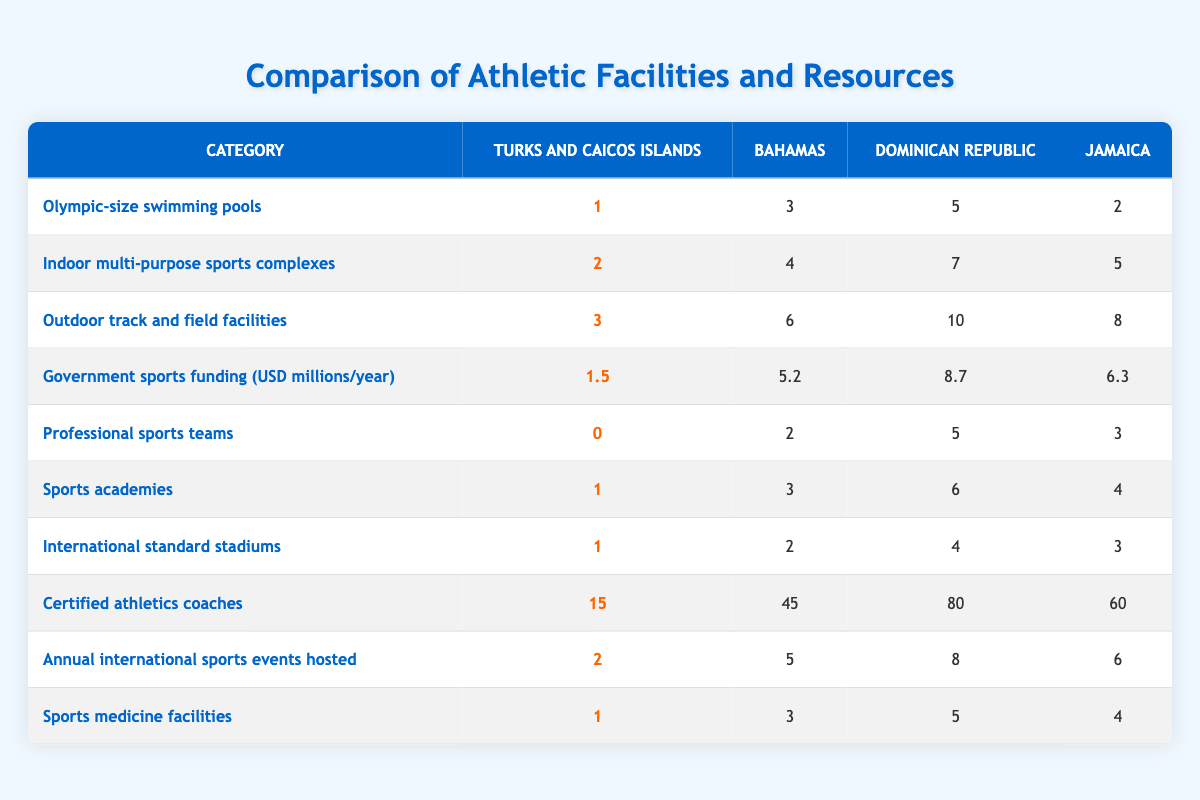What is the number of Olympic-size swimming pools in the Dominican Republic? The table shows that the Dominican Republic has 5 Olympic-size swimming pools listed under that category.
Answer: 5 Which country has the highest government sports funding? By looking at the government sports funding values, the Dominican Republic has the highest funding at 8.7 million USD per year.
Answer: Dominican Republic How many more certified athletics coaches does Jamaica have compared to the Turks and Caicos Islands? Jamaica has 60 certified athletics coaches and Turks and Caicos Islands has 15. The difference is 60 - 15 = 45.
Answer: 45 Do the Turks and Caicos Islands have more or fewer professional sports teams than the Bahamas? The Turks and Caicos Islands have 0 professional sports teams while the Bahamas have 2. Thus, Turks and Caicos has fewer professional teams.
Answer: Fewer What is the total number of outdoor track and field facilities across all four countries? Summing the outdoor track and field facilities: 3 (Turks and Caicos) + 6 (Bahamas) + 10 (Dominican Republic) + 8 (Jamaica) gives a total of 27 facilities.
Answer: 27 Which country has the least number of sports academies, and how many do they have? Turks and Caicos Islands has the least number of sports academies at 1, as seen in the comparison table.
Answer: Turks and Caicos Islands, 1 What is the average number of annual international sports events hosted by these countries? Adding the annual international sports events has the following values: 2 (Turks and Caicos) + 5 (Bahamas) + 8 (Dominican Republic) + 6 (Jamaica) = 21. Divided by 4 (the number of countries) gives an average of 21 / 4 = 5.25.
Answer: 5.25 Which country has the most international standard stadiums, and how many do they have? From the table, the Dominican Republic has the most international standard stadiums listed with a total of 4.
Answer: Dominican Republic, 4 What is the difference in the number of indoor multi-purpose sports complexes between the Dominican Republic and the Bahamas? The Dominican Republic has 7 indoor multi-purpose sports complexes and the Bahamas has 4. The difference is 7 - 4 = 3.
Answer: 3 